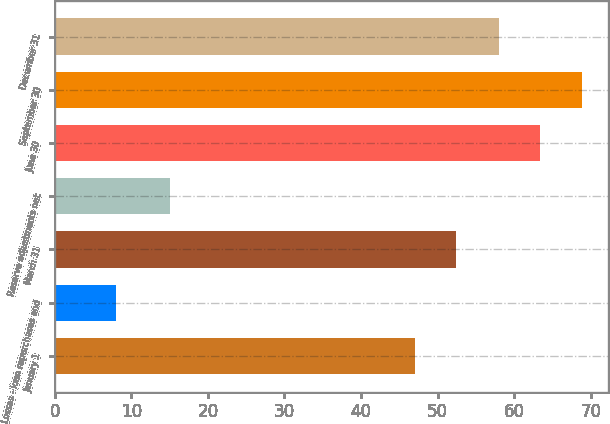Convert chart to OTSL. <chart><loc_0><loc_0><loc_500><loc_500><bar_chart><fcel>January 1<fcel>Losses - loan repurchases and<fcel>March 31<fcel>Reserve adjustments net<fcel>June 30<fcel>September 30<fcel>December 31<nl><fcel>47<fcel>8<fcel>52.4<fcel>15<fcel>63.4<fcel>68.8<fcel>58<nl></chart> 